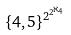Convert formula to latex. <formula><loc_0><loc_0><loc_500><loc_500>\{ 4 , 5 \} ^ { 2 ^ { 2 ^ { \aleph _ { 4 } } } }</formula> 